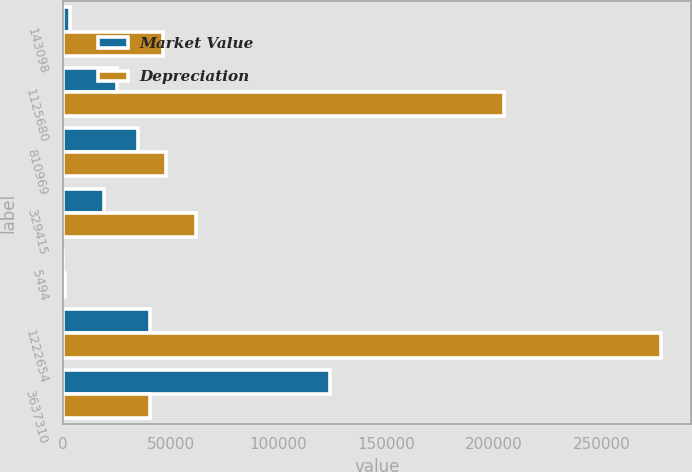<chart> <loc_0><loc_0><loc_500><loc_500><stacked_bar_chart><ecel><fcel>143098<fcel>1125680<fcel>810969<fcel>329415<fcel>5494<fcel>1222654<fcel>3637310<nl><fcel>Market Value<fcel>3503<fcel>25365<fcel>35169<fcel>19348<fcel>6<fcel>40442<fcel>123833<nl><fcel>Depreciation<fcel>46691<fcel>204779<fcel>48064<fcel>61629<fcel>1128<fcel>277534<fcel>40442<nl></chart> 